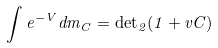Convert formula to latex. <formula><loc_0><loc_0><loc_500><loc_500>\int e ^ { - V } d m _ { C } = { \det } _ { 2 } ( 1 + v C )</formula> 